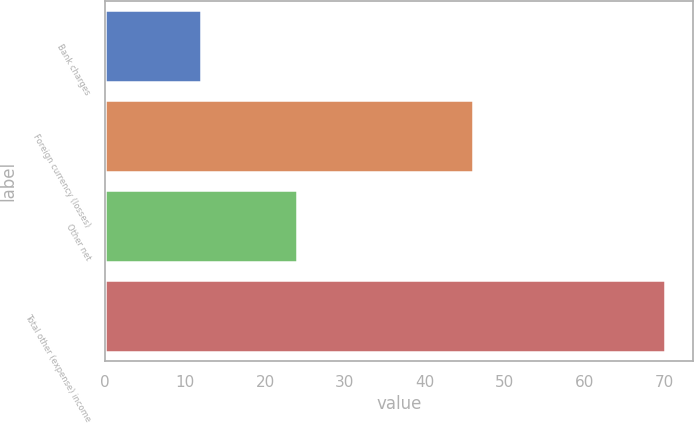Convert chart. <chart><loc_0><loc_0><loc_500><loc_500><bar_chart><fcel>Bank charges<fcel>Foreign currency (losses)<fcel>Other net<fcel>Total other (expense) income<nl><fcel>12<fcel>46<fcel>24<fcel>70<nl></chart> 